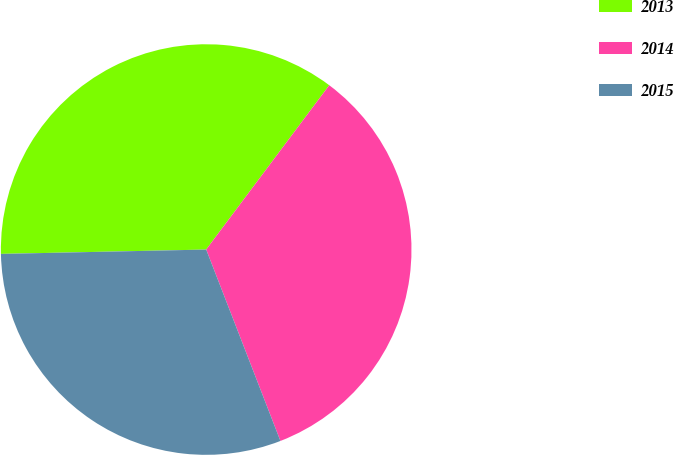Convert chart to OTSL. <chart><loc_0><loc_0><loc_500><loc_500><pie_chart><fcel>2013<fcel>2014<fcel>2015<nl><fcel>35.57%<fcel>33.88%<fcel>30.55%<nl></chart> 